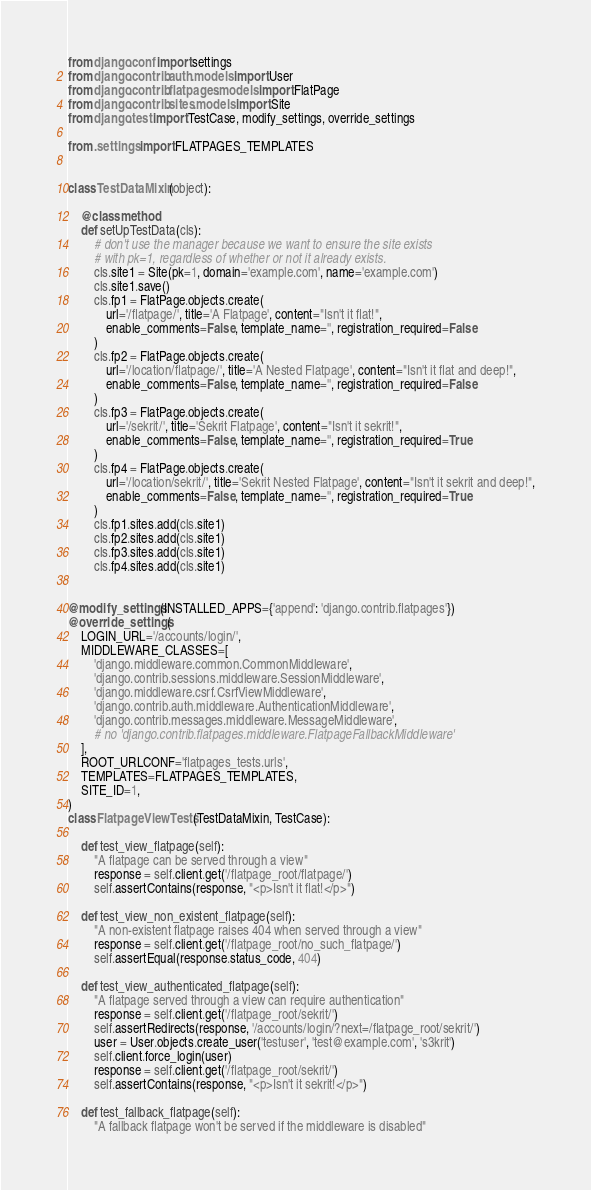<code> <loc_0><loc_0><loc_500><loc_500><_Python_>from django.conf import settings
from django.contrib.auth.models import User
from django.contrib.flatpages.models import FlatPage
from django.contrib.sites.models import Site
from django.test import TestCase, modify_settings, override_settings

from .settings import FLATPAGES_TEMPLATES


class TestDataMixin(object):

    @classmethod
    def setUpTestData(cls):
        # don't use the manager because we want to ensure the site exists
        # with pk=1, regardless of whether or not it already exists.
        cls.site1 = Site(pk=1, domain='example.com', name='example.com')
        cls.site1.save()
        cls.fp1 = FlatPage.objects.create(
            url='/flatpage/', title='A Flatpage', content="Isn't it flat!",
            enable_comments=False, template_name='', registration_required=False
        )
        cls.fp2 = FlatPage.objects.create(
            url='/location/flatpage/', title='A Nested Flatpage', content="Isn't it flat and deep!",
            enable_comments=False, template_name='', registration_required=False
        )
        cls.fp3 = FlatPage.objects.create(
            url='/sekrit/', title='Sekrit Flatpage', content="Isn't it sekrit!",
            enable_comments=False, template_name='', registration_required=True
        )
        cls.fp4 = FlatPage.objects.create(
            url='/location/sekrit/', title='Sekrit Nested Flatpage', content="Isn't it sekrit and deep!",
            enable_comments=False, template_name='', registration_required=True
        )
        cls.fp1.sites.add(cls.site1)
        cls.fp2.sites.add(cls.site1)
        cls.fp3.sites.add(cls.site1)
        cls.fp4.sites.add(cls.site1)


@modify_settings(INSTALLED_APPS={'append': 'django.contrib.flatpages'})
@override_settings(
    LOGIN_URL='/accounts/login/',
    MIDDLEWARE_CLASSES=[
        'django.middleware.common.CommonMiddleware',
        'django.contrib.sessions.middleware.SessionMiddleware',
        'django.middleware.csrf.CsrfViewMiddleware',
        'django.contrib.auth.middleware.AuthenticationMiddleware',
        'django.contrib.messages.middleware.MessageMiddleware',
        # no 'django.contrib.flatpages.middleware.FlatpageFallbackMiddleware'
    ],
    ROOT_URLCONF='flatpages_tests.urls',
    TEMPLATES=FLATPAGES_TEMPLATES,
    SITE_ID=1,
)
class FlatpageViewTests(TestDataMixin, TestCase):

    def test_view_flatpage(self):
        "A flatpage can be served through a view"
        response = self.client.get('/flatpage_root/flatpage/')
        self.assertContains(response, "<p>Isn't it flat!</p>")

    def test_view_non_existent_flatpage(self):
        "A non-existent flatpage raises 404 when served through a view"
        response = self.client.get('/flatpage_root/no_such_flatpage/')
        self.assertEqual(response.status_code, 404)

    def test_view_authenticated_flatpage(self):
        "A flatpage served through a view can require authentication"
        response = self.client.get('/flatpage_root/sekrit/')
        self.assertRedirects(response, '/accounts/login/?next=/flatpage_root/sekrit/')
        user = User.objects.create_user('testuser', 'test@example.com', 's3krit')
        self.client.force_login(user)
        response = self.client.get('/flatpage_root/sekrit/')
        self.assertContains(response, "<p>Isn't it sekrit!</p>")

    def test_fallback_flatpage(self):
        "A fallback flatpage won't be served if the middleware is disabled"</code> 